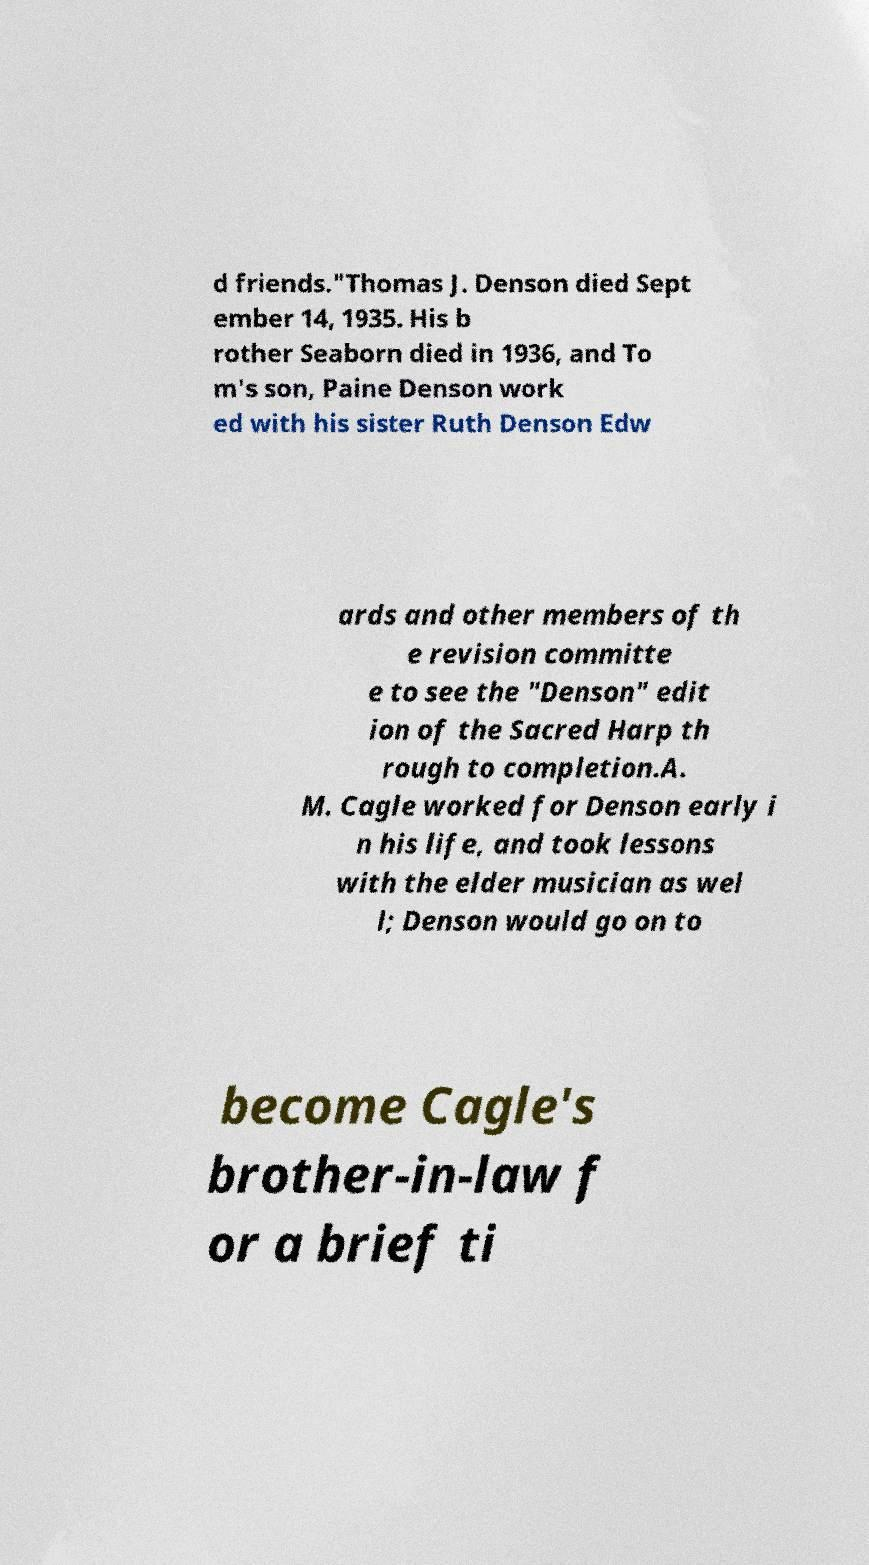Could you assist in decoding the text presented in this image and type it out clearly? d friends."Thomas J. Denson died Sept ember 14, 1935. His b rother Seaborn died in 1936, and To m's son, Paine Denson work ed with his sister Ruth Denson Edw ards and other members of th e revision committe e to see the "Denson" edit ion of the Sacred Harp th rough to completion.A. M. Cagle worked for Denson early i n his life, and took lessons with the elder musician as wel l; Denson would go on to become Cagle's brother-in-law f or a brief ti 